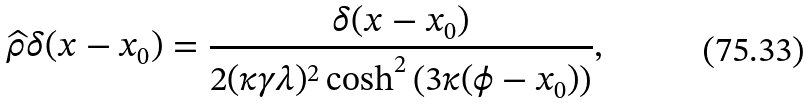<formula> <loc_0><loc_0><loc_500><loc_500>\widehat { \rho } \delta ( x - x _ { 0 } ) = \frac { \delta ( x - x _ { 0 } ) } { 2 ( \kappa \gamma \lambda ) ^ { 2 } \cosh ^ { 2 } \left ( 3 \kappa ( \phi - x _ { 0 } ) \right ) } ,</formula> 